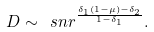Convert formula to latex. <formula><loc_0><loc_0><loc_500><loc_500>D \sim \ s n r ^ { \frac { \delta _ { 1 } \left ( 1 - \mu \right ) - \delta _ { 2 } } { 1 - \delta _ { 1 } } } .</formula> 